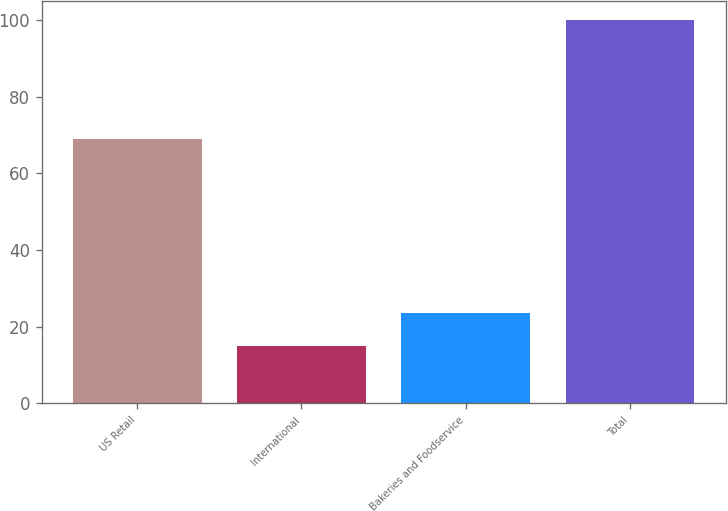<chart> <loc_0><loc_0><loc_500><loc_500><bar_chart><fcel>US Retail<fcel>International<fcel>Bakeries and Foodservice<fcel>Total<nl><fcel>69<fcel>15<fcel>23.5<fcel>100<nl></chart> 